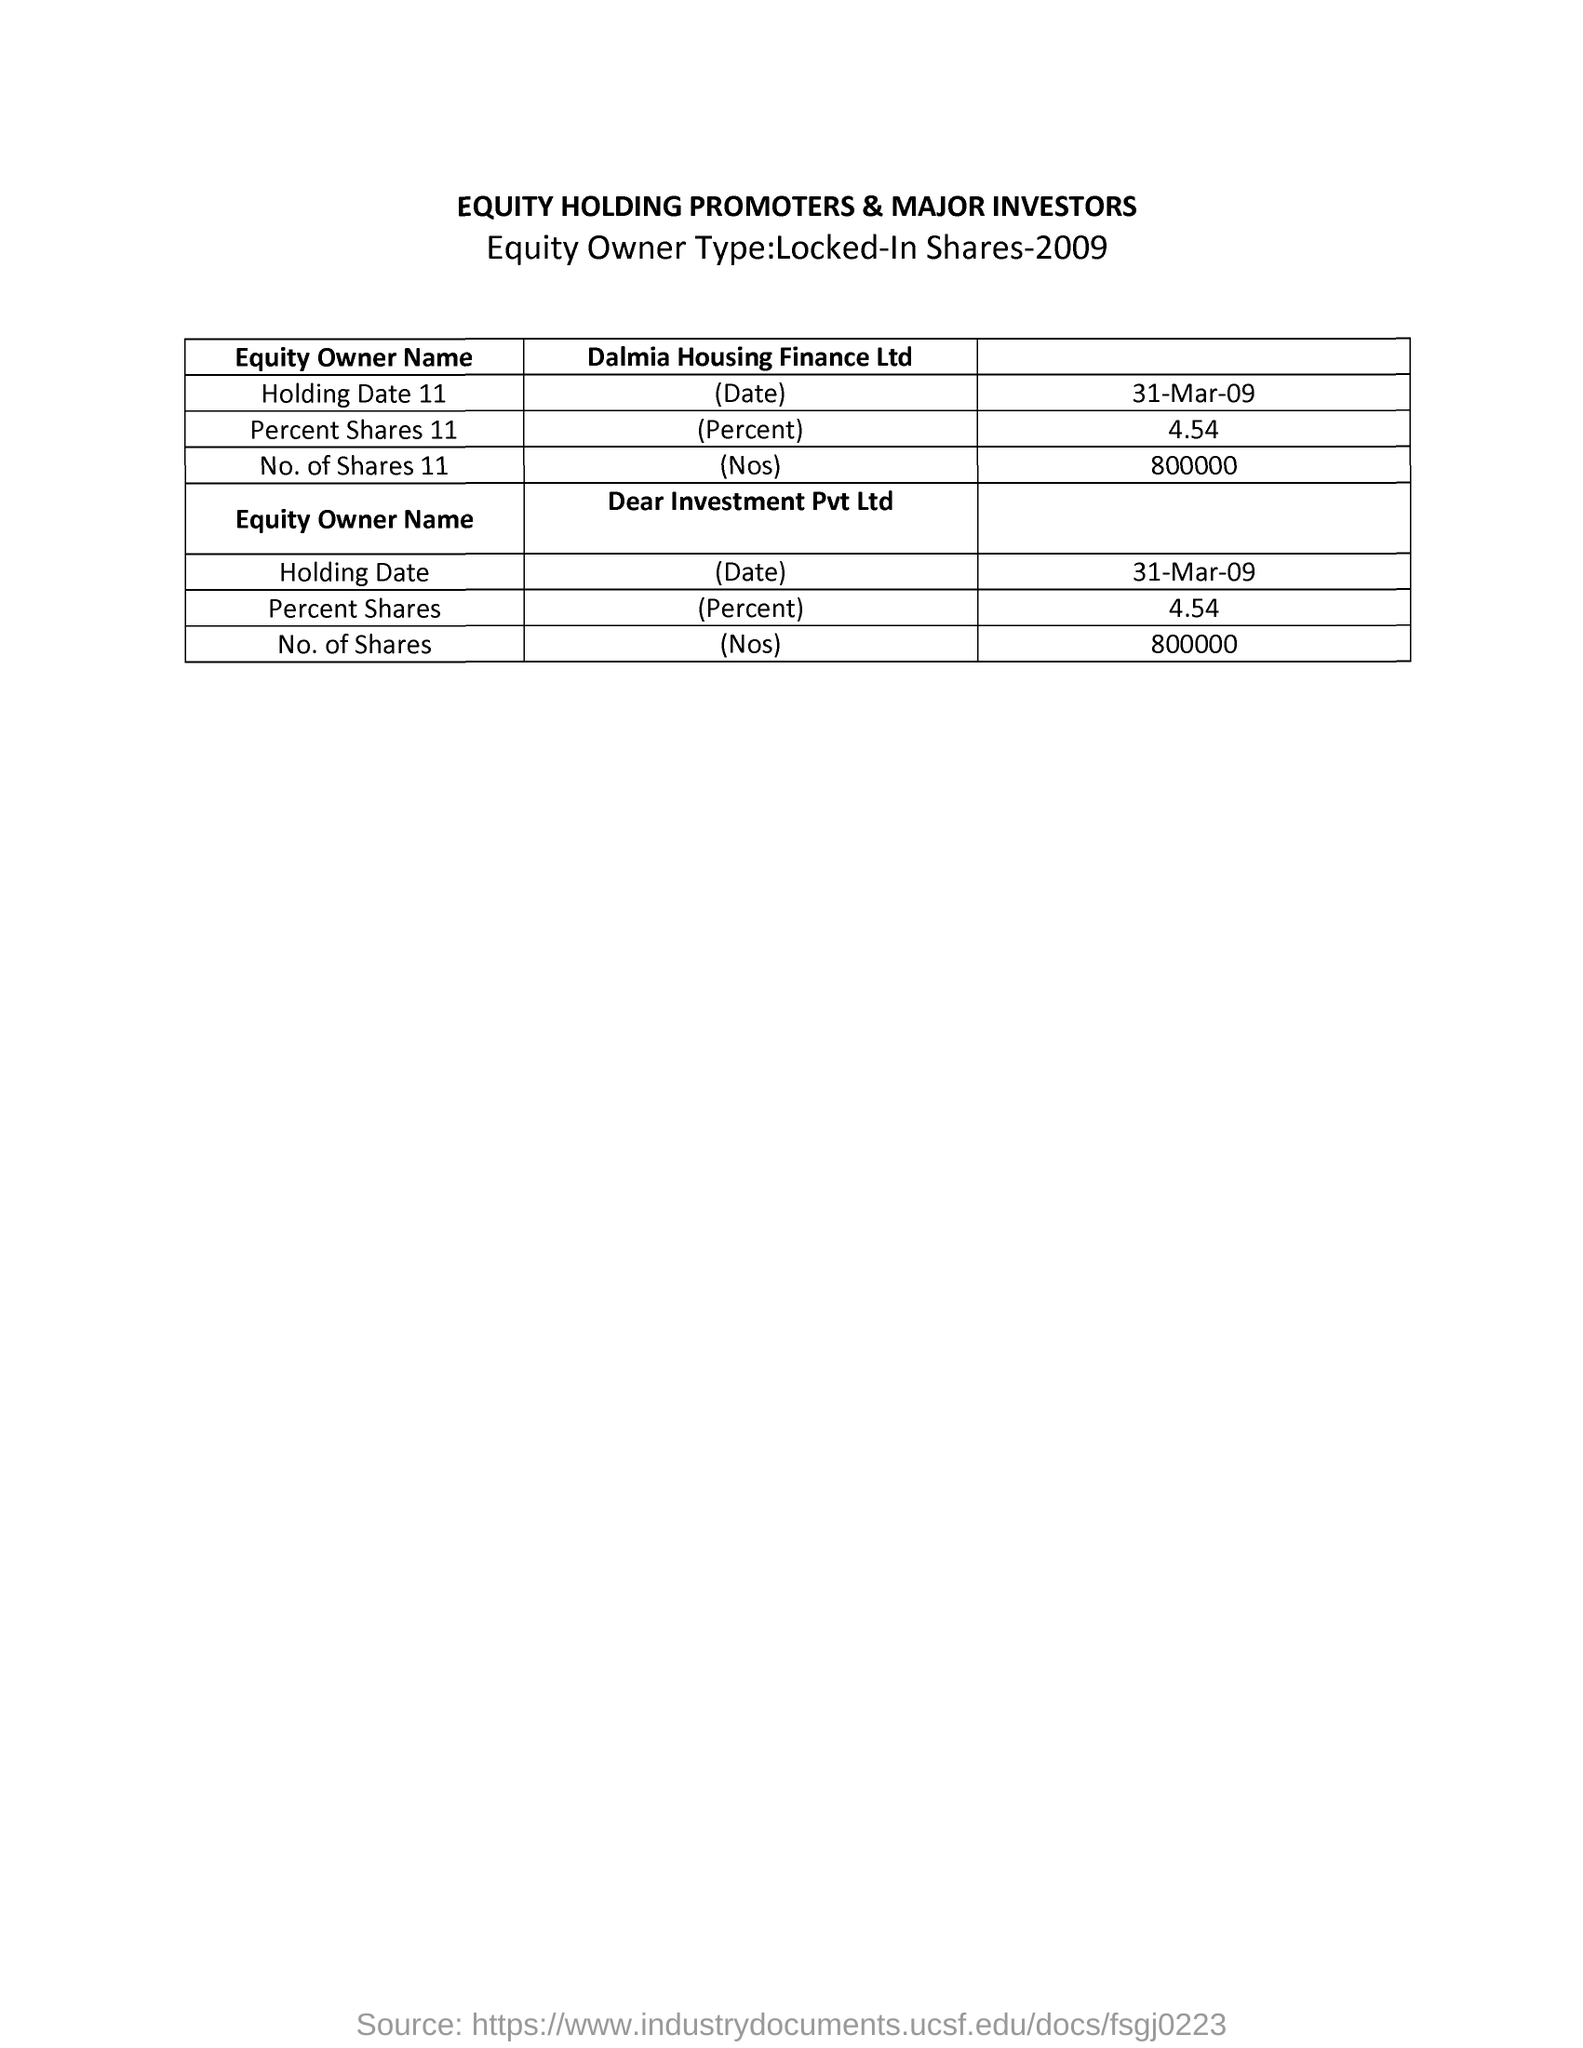Mention a couple of crucial points in this snapshot. The document is titled "Equity Holding Promoters & Major Investors. The locked-in shares from 2009 are the equity owner type. The second equity owner is Dear Investment Pvt Ltd. What is the percentage of shares owned by Dalmia Housing Finance Ltd, specifically the 11th percentile? The percentage is 4.54. The 'Holding Date' of 'Dear Investment Pvt Ltd' is March 31, 2009. 